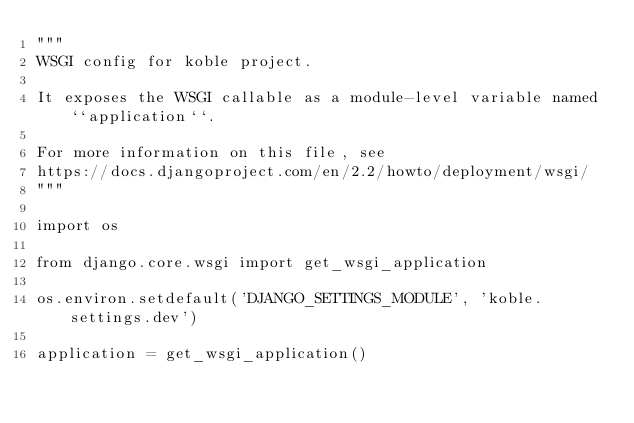Convert code to text. <code><loc_0><loc_0><loc_500><loc_500><_Python_>"""
WSGI config for koble project.

It exposes the WSGI callable as a module-level variable named ``application``.

For more information on this file, see
https://docs.djangoproject.com/en/2.2/howto/deployment/wsgi/
"""

import os

from django.core.wsgi import get_wsgi_application

os.environ.setdefault('DJANGO_SETTINGS_MODULE', 'koble.settings.dev')

application = get_wsgi_application()
</code> 